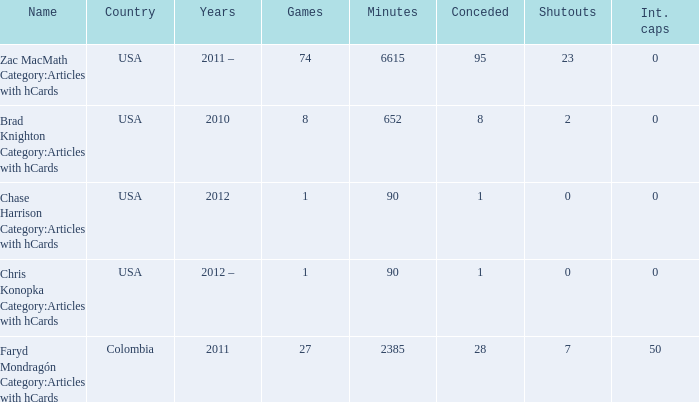When chase harrison category:articles with hcards is the name what is the year? 2012.0. 